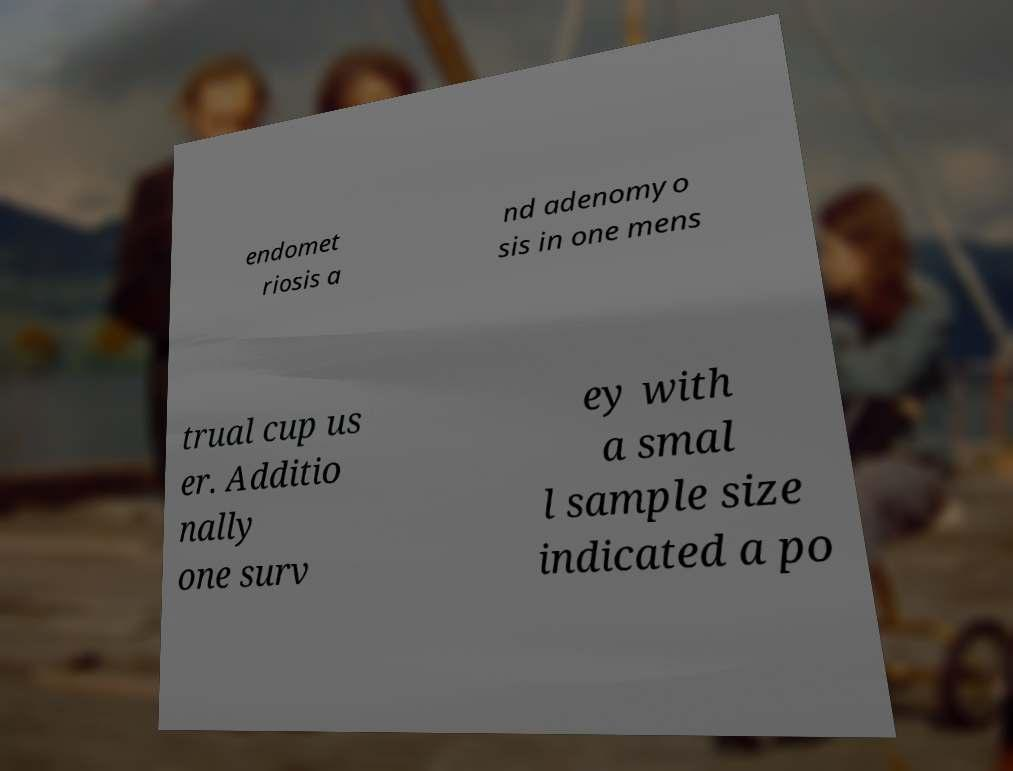Can you read and provide the text displayed in the image?This photo seems to have some interesting text. Can you extract and type it out for me? endomet riosis a nd adenomyo sis in one mens trual cup us er. Additio nally one surv ey with a smal l sample size indicated a po 